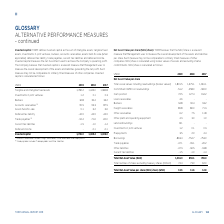According to Torm's financial document, What does TORM believe that the NAV/share is a relevant measure for? Management uses to measure the overall development of the assets and liabilities per share.. The document states: "eves that the NAV/share is a relevant measure that Management uses to measure the overall development of the assets and liabilities per share. Such me..." Also, How is NAV/share calculated? using broker values of vessels and excluding charter commitments. The document states: "sures of other companies. NAV/share is calculated using broker values of vessels and excluding charter commitments. NAV/share is calculated as follows..." Also, For which years is the Total Net Asset Value per share (NAV/share) calculated? The document contains multiple relevant values: 2019, 2018, 2017. From the document: "USDm 2019 2018 2017 USDm 2019 2018 2017 USDm 2019 2018 2017..." Additionally, In which year was the Total Net Asset Value per share (NAV/share) the largest? According to the financial document, 2019. The relevant text states: "USDm 2019 2018 2017..." Also, can you calculate: What was the change in the Total Net Asset Value (NAV) in 2019 from 2018? Based on the calculation: 1,016.0-856.1, the result is 159.9 (in millions). This is based on the information: "Total Net Asset Value (NAV) 1,016.0 856.1 796.0 Total Net Asset Value (NAV) 1,016.0 856.1 796.0..." The key data points involved are: 1,016.0, 856.1. Also, can you calculate: What was the percentage change in the Total Net Asset Value (NAV) in 2019 from 2018? To answer this question, I need to perform calculations using the financial data. The calculation is: (1,016.0-856.1)/856.1, which equals 18.68 (percentage). This is based on the information: "Total Net Asset Value (NAV) 1,016.0 856.1 796.0 Total Net Asset Value (NAV) 1,016.0 856.1 796.0..." The key data points involved are: 1,016.0, 856.1. 